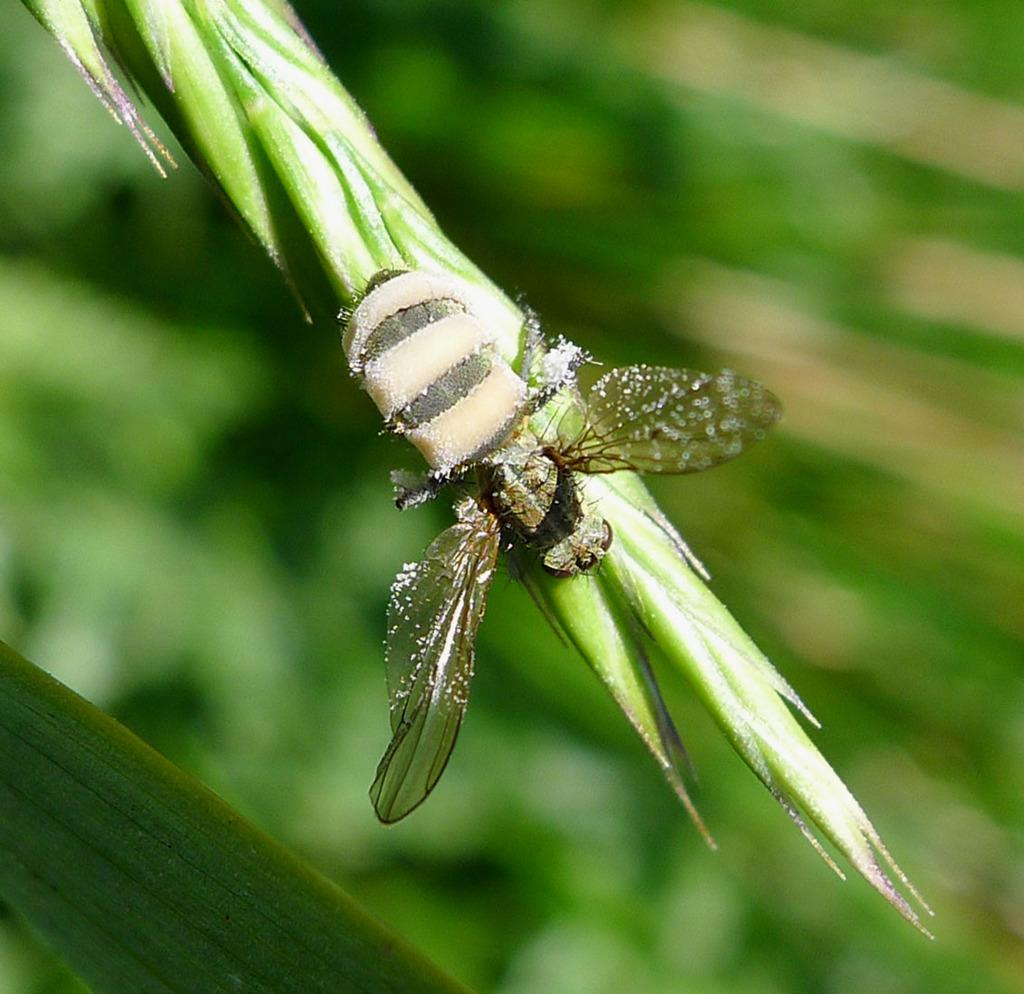What is the main subject of the image? There is an insect in the image. Where is the insect located? The insect is on a leaf. Can you describe the background of the image? The background of the image is blurred. How does the insect increase the volume of the dock in the image? There is no dock present in the image, and the insect does not interact with any dock. 